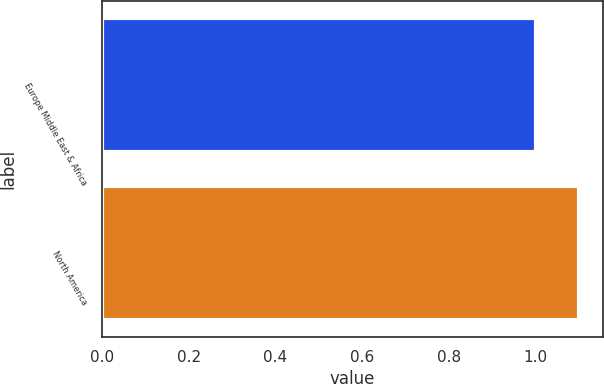Convert chart to OTSL. <chart><loc_0><loc_0><loc_500><loc_500><bar_chart><fcel>Europe Middle East & Africa<fcel>North America<nl><fcel>1<fcel>1.1<nl></chart> 